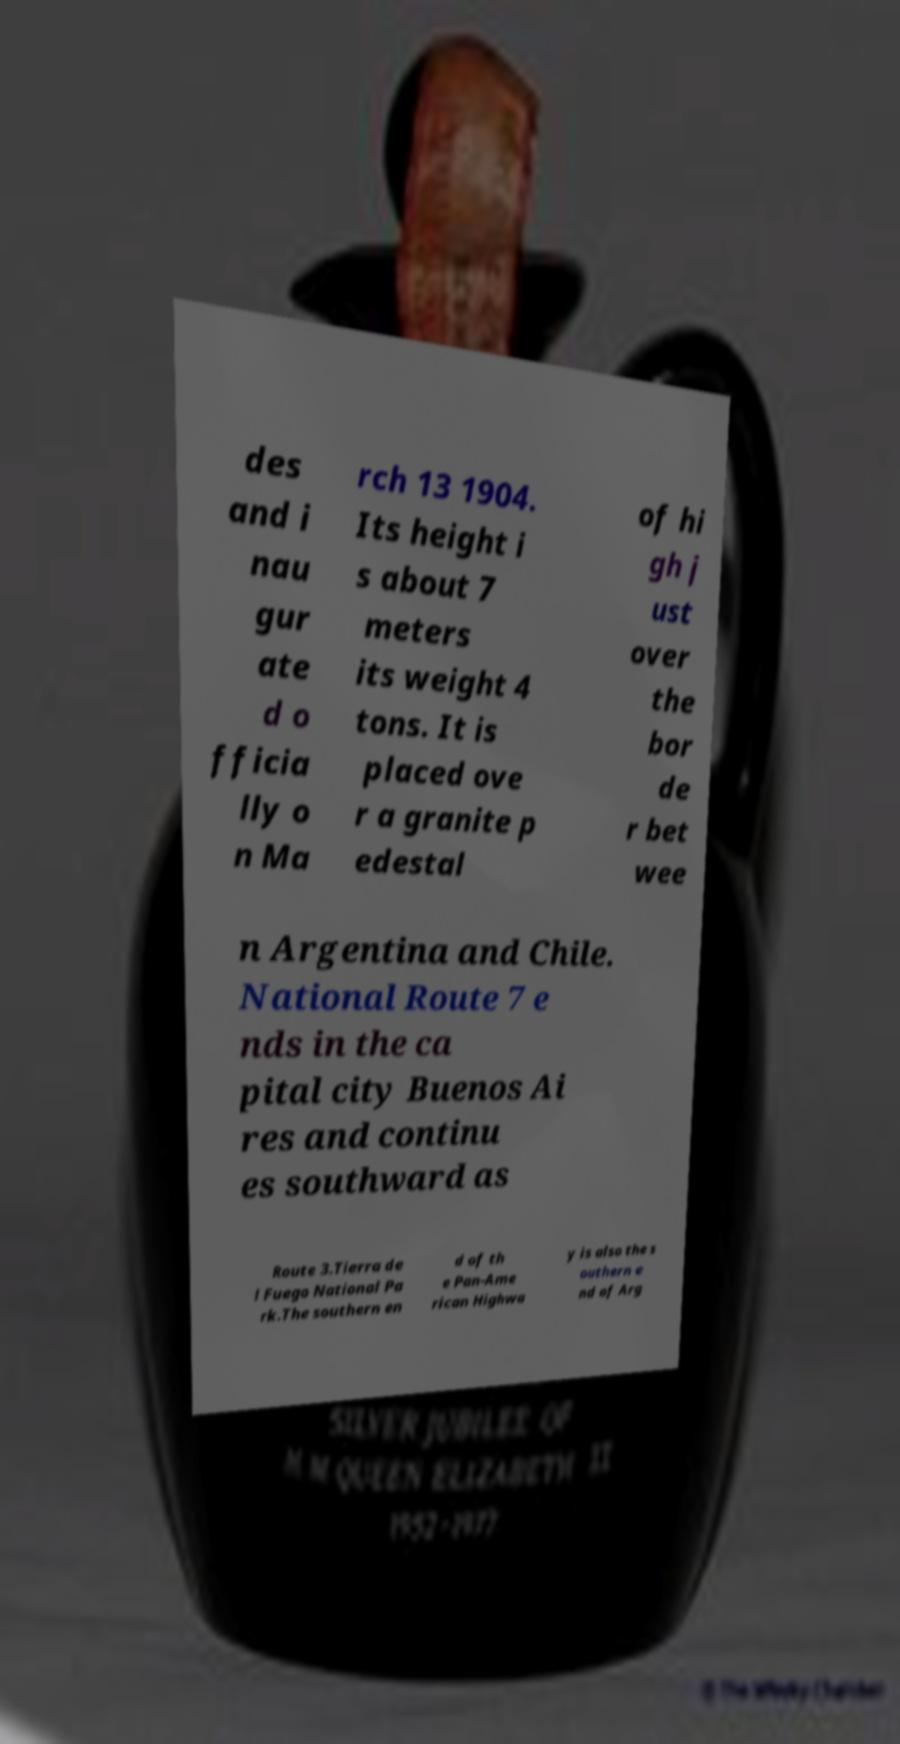I need the written content from this picture converted into text. Can you do that? des and i nau gur ate d o fficia lly o n Ma rch 13 1904. Its height i s about 7 meters its weight 4 tons. It is placed ove r a granite p edestal of hi gh j ust over the bor de r bet wee n Argentina and Chile. National Route 7 e nds in the ca pital city Buenos Ai res and continu es southward as Route 3.Tierra de l Fuego National Pa rk.The southern en d of th e Pan-Ame rican Highwa y is also the s outhern e nd of Arg 